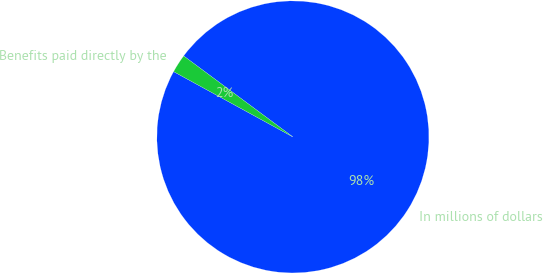<chart> <loc_0><loc_0><loc_500><loc_500><pie_chart><fcel>In millions of dollars<fcel>Benefits paid directly by the<nl><fcel>97.82%<fcel>2.18%<nl></chart> 